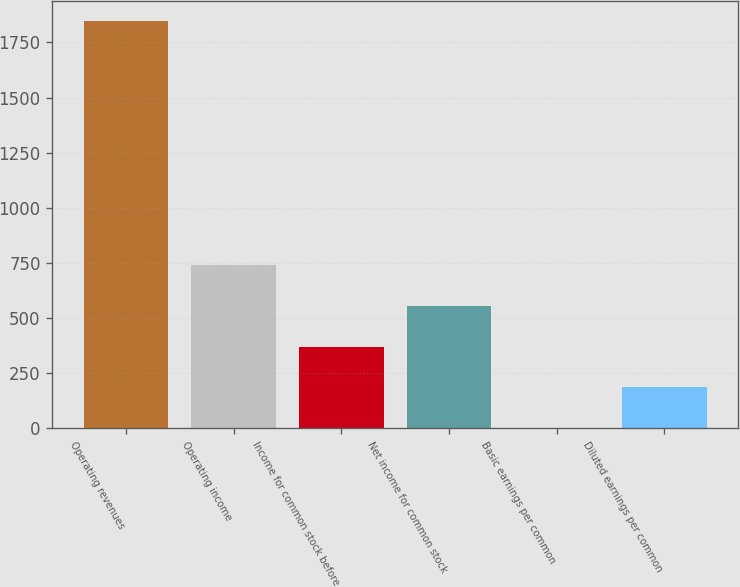<chart> <loc_0><loc_0><loc_500><loc_500><bar_chart><fcel>Operating revenues<fcel>Operating income<fcel>Income for common stock before<fcel>Net income for common stock<fcel>Basic earnings per common<fcel>Diluted earnings per common<nl><fcel>1848<fcel>739.46<fcel>369.96<fcel>554.71<fcel>0.46<fcel>185.21<nl></chart> 